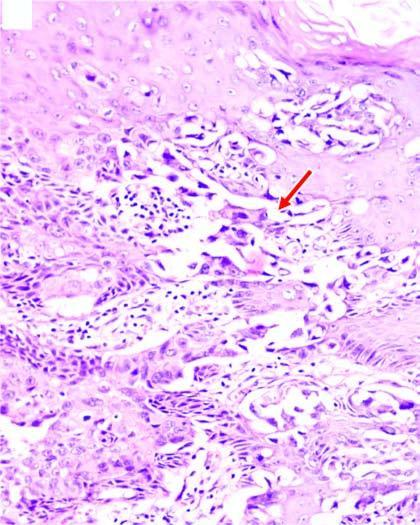re these cases clefts in the epidermal layers containing large tumour cells?
Answer the question using a single word or phrase. No 